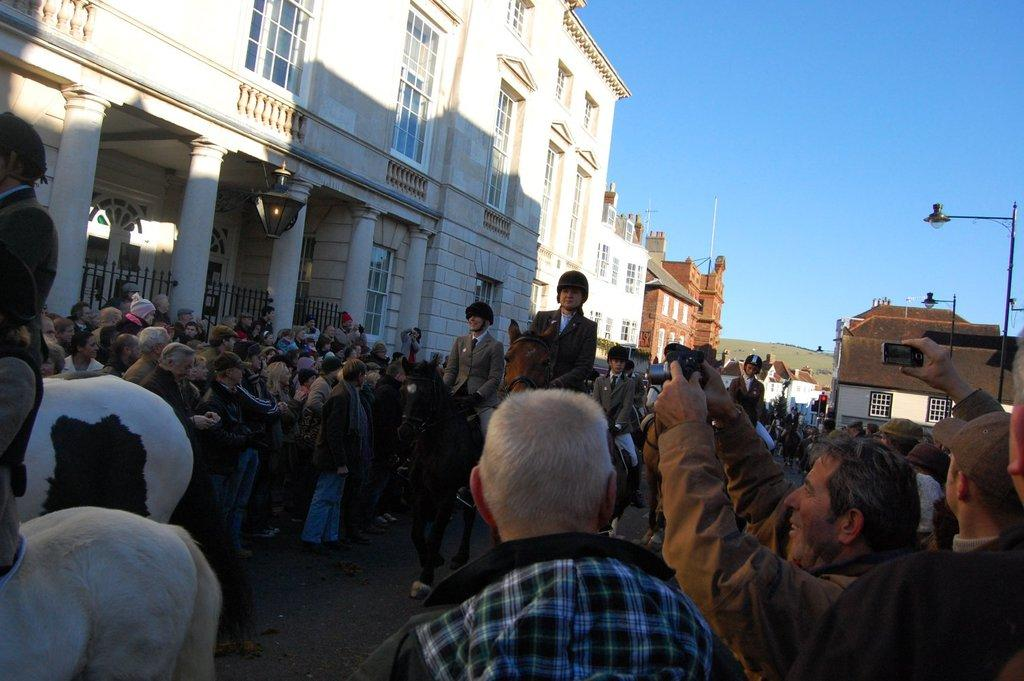What are the people doing in the image? The people are sitting on horses in the image. What else can be seen in the image besides the people on horses? There are people standing on a path, poles with lights, buildings, a hill, and the sky visible in the background of the image. What type of flame can be seen coming from the baseball in the image? There is no baseball present in the image, and therefore no flame can be seen coming from it. 